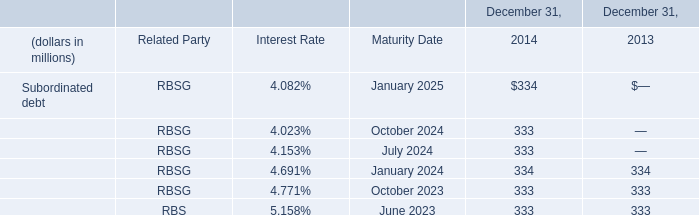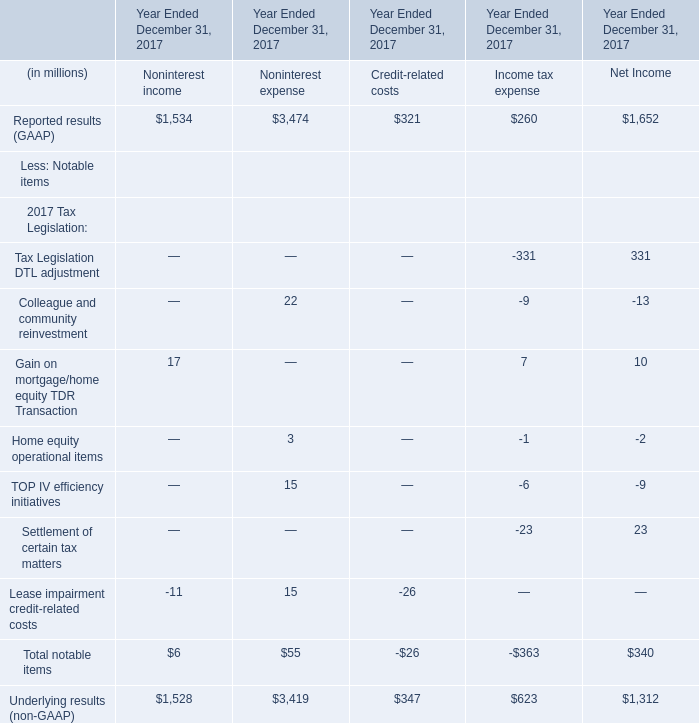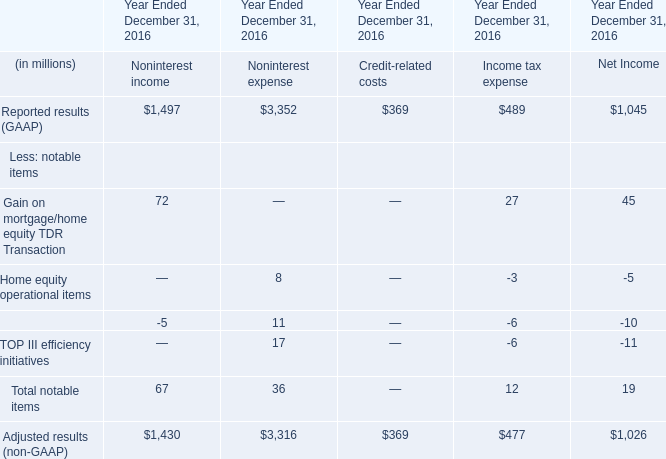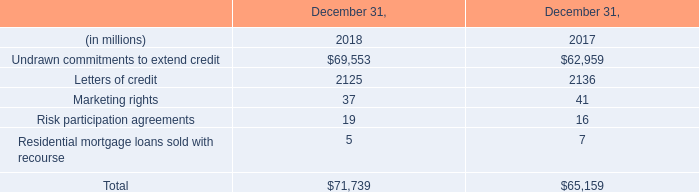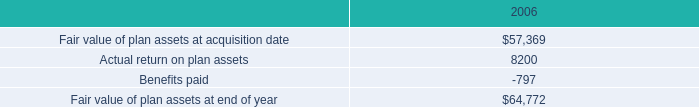In which section the sum of notable items in non-interest expense has the highest value? (in million) 
Computations: ((8 + 11) + 17)
Answer: 36.0. 